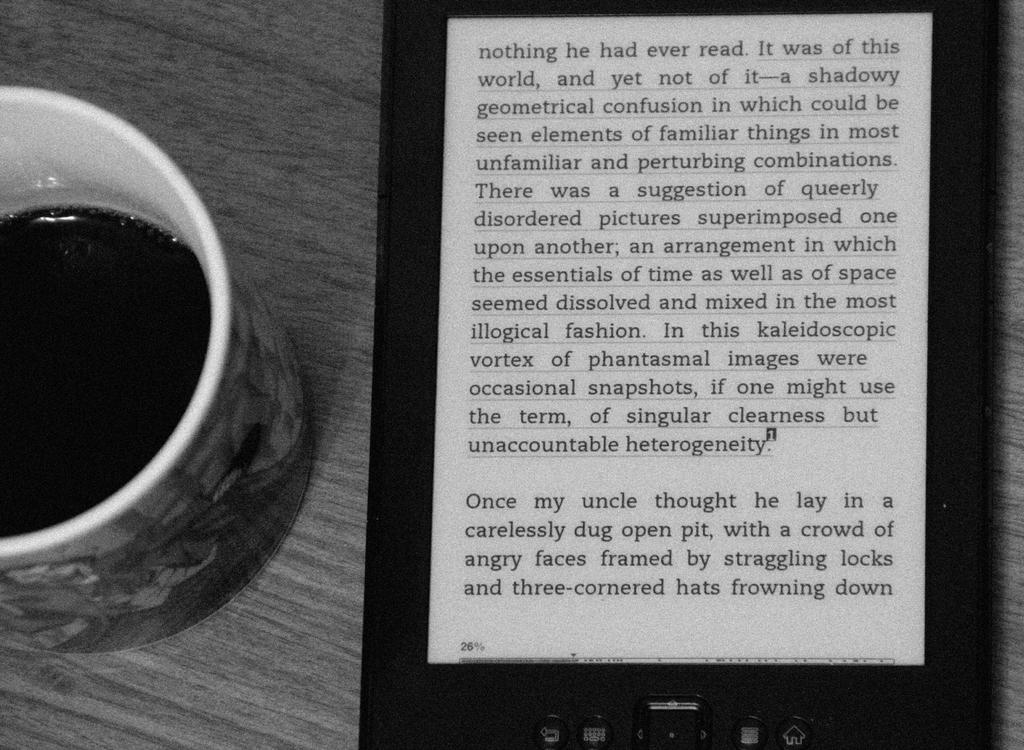Provide a one-sentence caption for the provided image. A mug of coffee is placed on a table next to an electronic device displaying a story about someones uncle. 